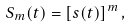<formula> <loc_0><loc_0><loc_500><loc_500>S _ { m } ( t ) = \left [ s ( t ) \right ] ^ { m } ,</formula> 